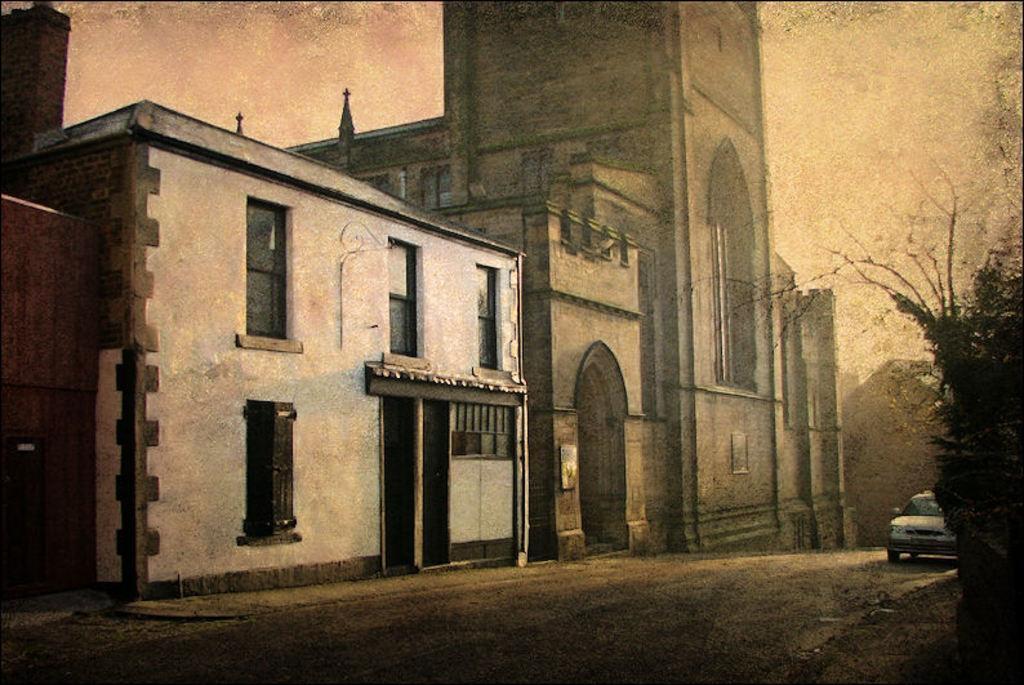Please provide a concise description of this image. In this image we can see a car on the road and buildings. There is a plant on the right side of the image. 